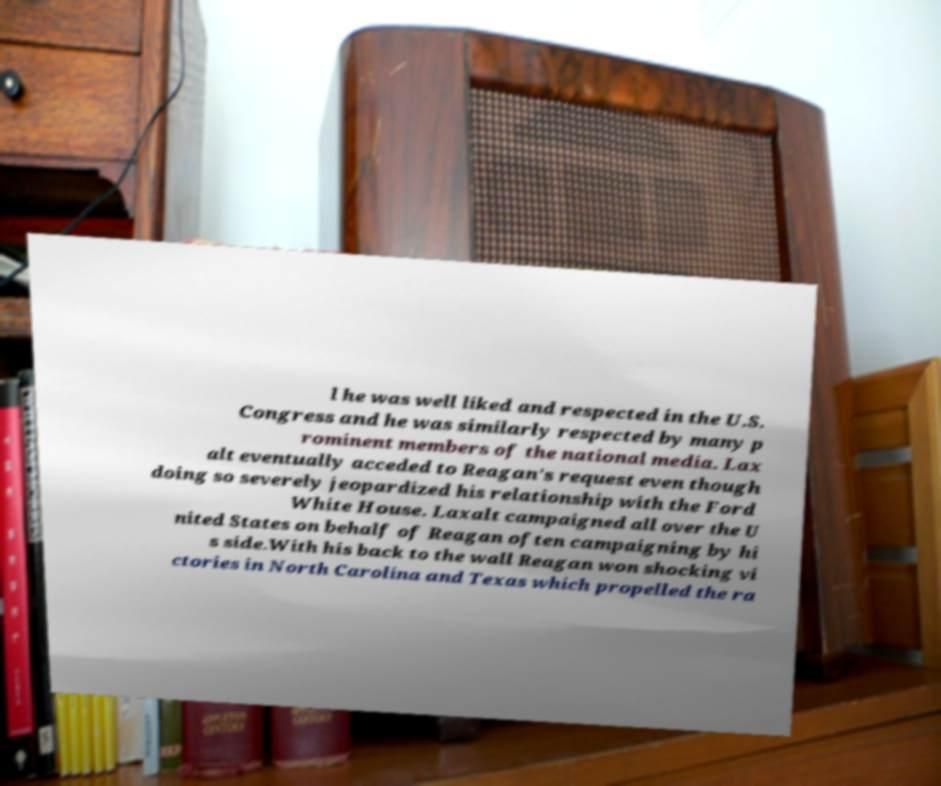Can you accurately transcribe the text from the provided image for me? l he was well liked and respected in the U.S. Congress and he was similarly respected by many p rominent members of the national media. Lax alt eventually acceded to Reagan's request even though doing so severely jeopardized his relationship with the Ford White House. Laxalt campaigned all over the U nited States on behalf of Reagan often campaigning by hi s side.With his back to the wall Reagan won shocking vi ctories in North Carolina and Texas which propelled the ra 